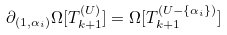Convert formula to latex. <formula><loc_0><loc_0><loc_500><loc_500>\partial _ { ( 1 , \alpha _ { i } ) } \Omega [ T ^ { ( U ) } _ { k + 1 } ] = \Omega [ T ^ { ( U - \{ \alpha _ { i } \} ) } _ { k + 1 } ]</formula> 